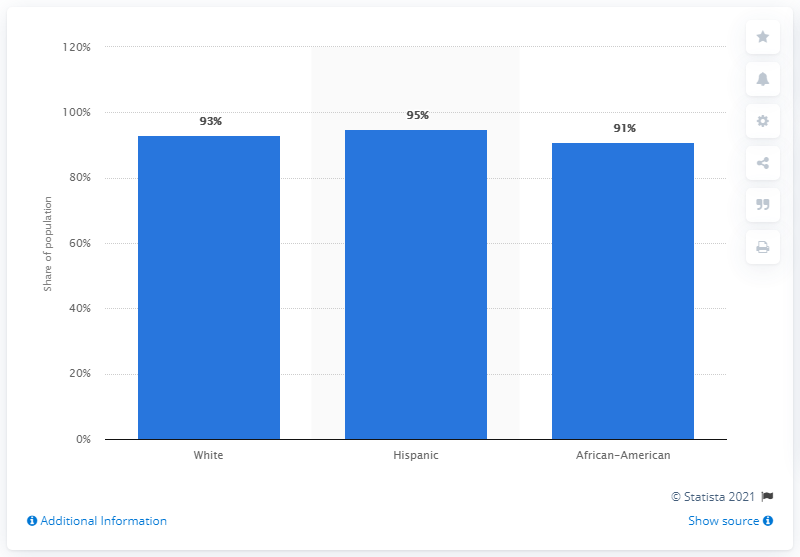Identify some key points in this picture. The race that has the largest proportion of adults is Hispanic. The average of three races is 93. 